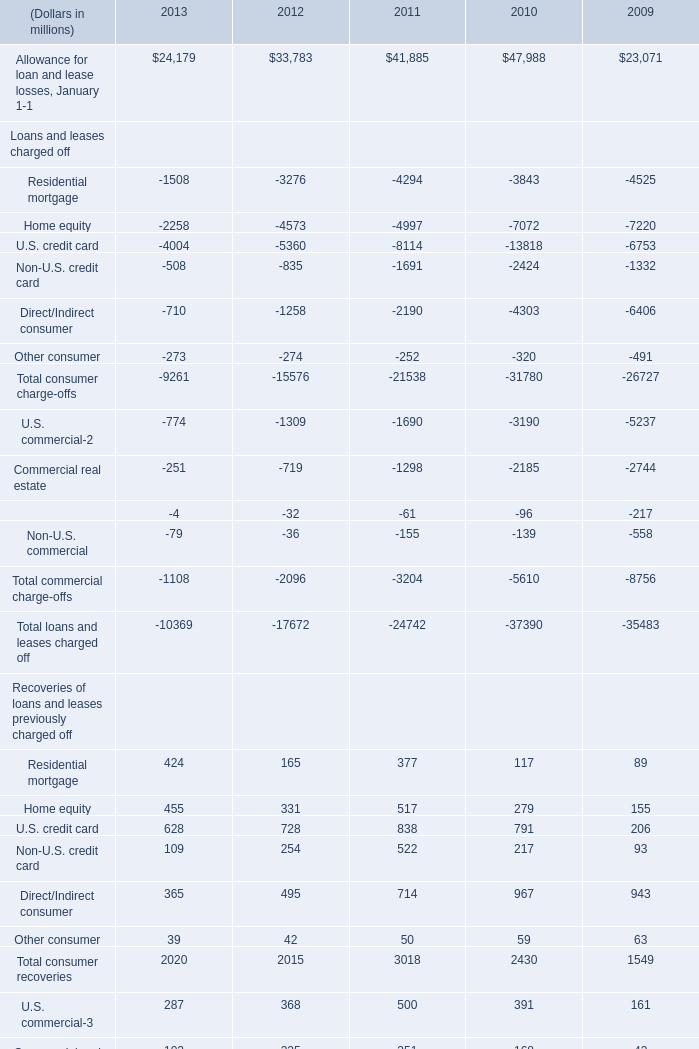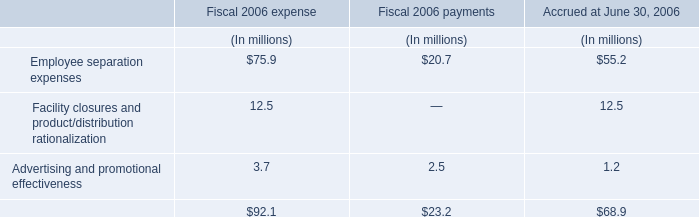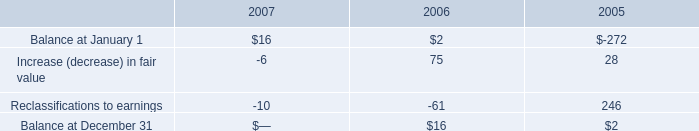Which year is Home equity in Recoveries of loans and leases previously charged off the highest? 
Answer: 2011. 